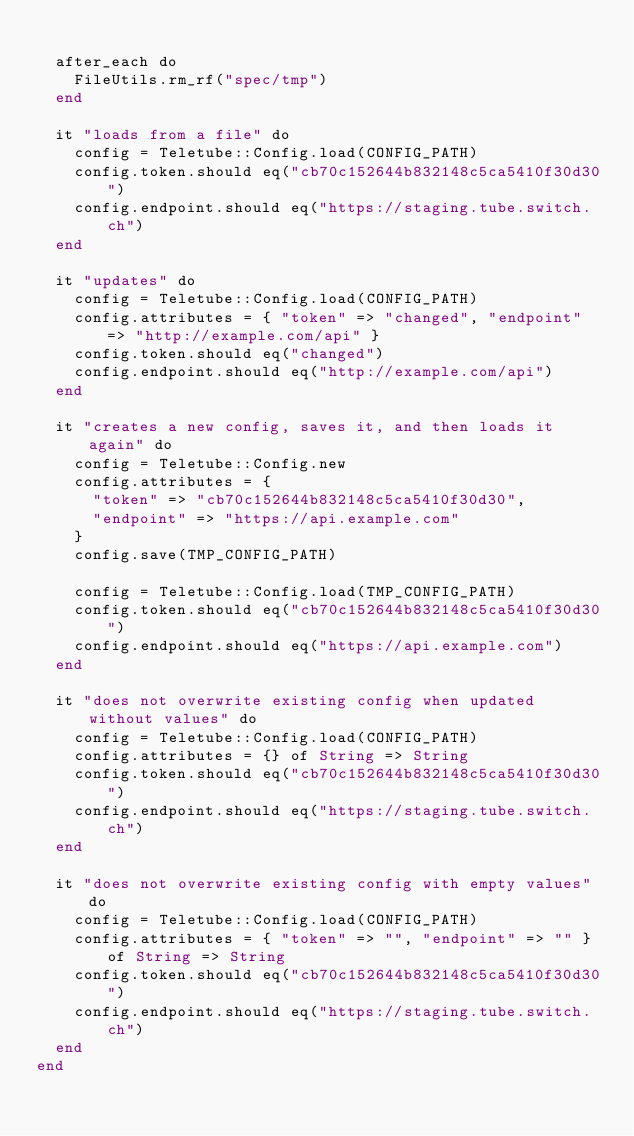Convert code to text. <code><loc_0><loc_0><loc_500><loc_500><_Crystal_>
  after_each do
    FileUtils.rm_rf("spec/tmp")
  end

  it "loads from a file" do
    config = Teletube::Config.load(CONFIG_PATH)
    config.token.should eq("cb70c152644b832148c5ca5410f30d30")
    config.endpoint.should eq("https://staging.tube.switch.ch")
  end

  it "updates" do
    config = Teletube::Config.load(CONFIG_PATH)
    config.attributes = { "token" => "changed", "endpoint" => "http://example.com/api" }
    config.token.should eq("changed")
    config.endpoint.should eq("http://example.com/api")
  end

  it "creates a new config, saves it, and then loads it again" do
    config = Teletube::Config.new
    config.attributes = {
      "token" => "cb70c152644b832148c5ca5410f30d30",
      "endpoint" => "https://api.example.com"
    }
    config.save(TMP_CONFIG_PATH)

    config = Teletube::Config.load(TMP_CONFIG_PATH)
    config.token.should eq("cb70c152644b832148c5ca5410f30d30")
    config.endpoint.should eq("https://api.example.com")
  end

  it "does not overwrite existing config when updated without values" do
    config = Teletube::Config.load(CONFIG_PATH)
    config.attributes = {} of String => String
    config.token.should eq("cb70c152644b832148c5ca5410f30d30")
    config.endpoint.should eq("https://staging.tube.switch.ch")
  end

  it "does not overwrite existing config with empty values" do
    config = Teletube::Config.load(CONFIG_PATH)
    config.attributes = { "token" => "", "endpoint" => "" } of String => String
    config.token.should eq("cb70c152644b832148c5ca5410f30d30")
    config.endpoint.should eq("https://staging.tube.switch.ch")
  end
end
</code> 